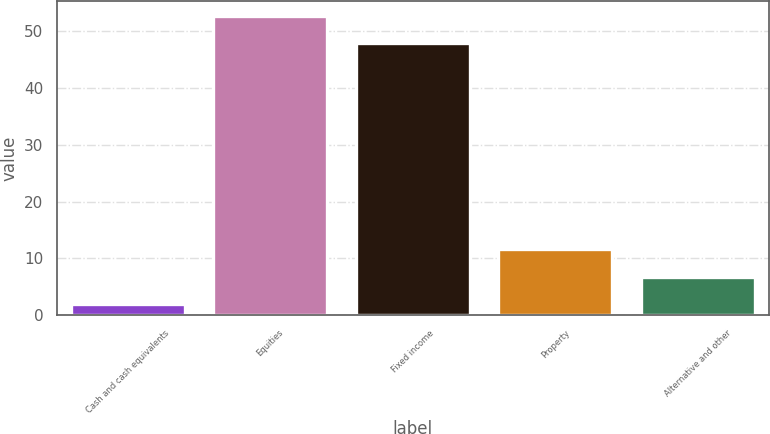Convert chart. <chart><loc_0><loc_0><loc_500><loc_500><bar_chart><fcel>Cash and cash equivalents<fcel>Equities<fcel>Fixed income<fcel>Property<fcel>Alternative and other<nl><fcel>2<fcel>52.8<fcel>48<fcel>11.6<fcel>6.8<nl></chart> 